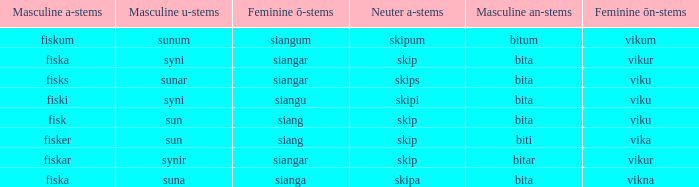How is the masculine version of the word expressed, which has a feminine ö ending as in siangar and a masculine u ending as in sunar? Bita. 